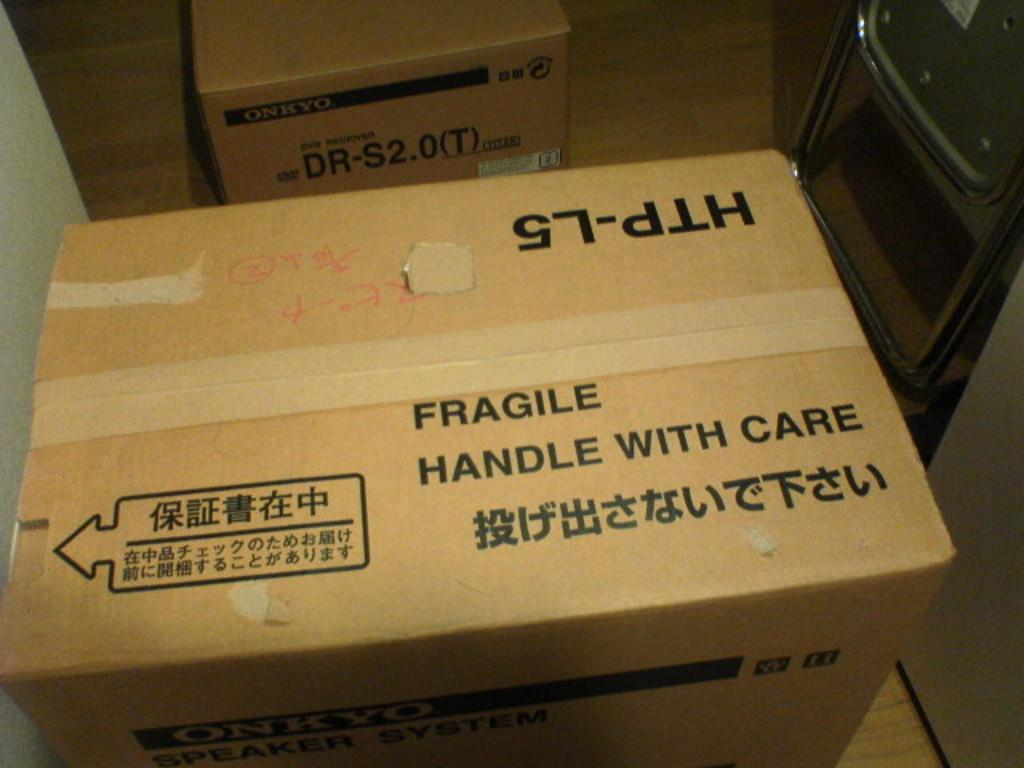<image>
Relay a brief, clear account of the picture shown. an image of a box that states 'FRAGILE HANDLE WITH CARE" 